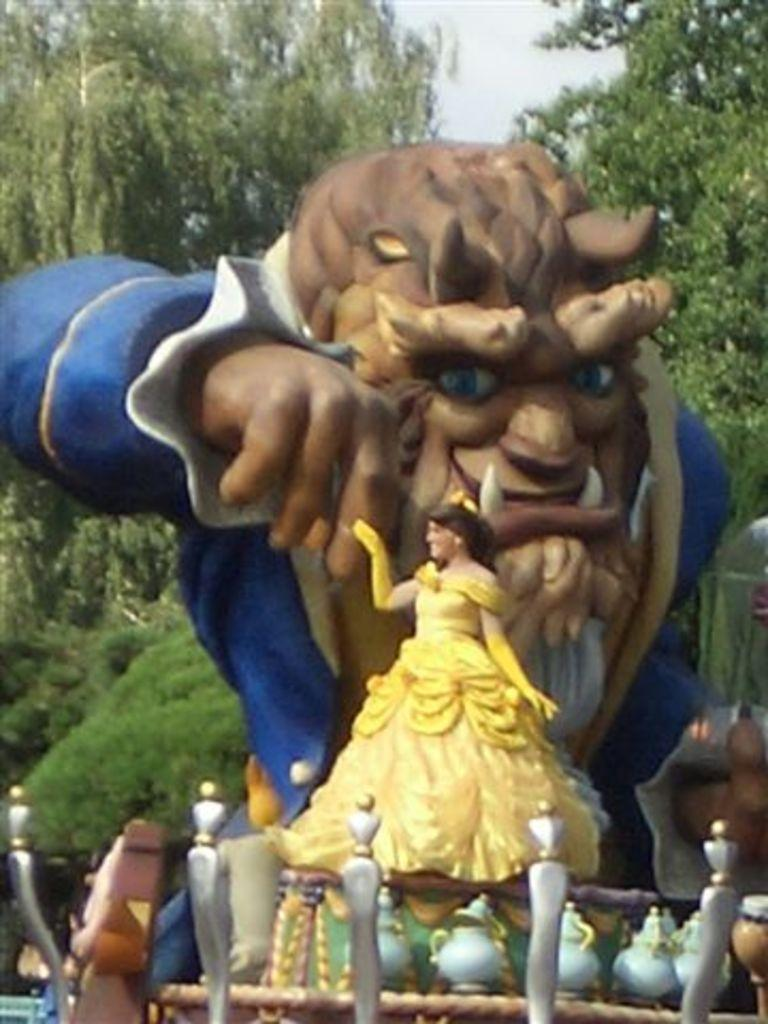What is the main subject in the center of the image? There is a statue in the center of the image. What can be seen in the background of the image? There are trees and the sky visible in the background of the image. Can you see a zebra playing in the background of the image? No, there is no zebra or any playful activity visible in the image. 